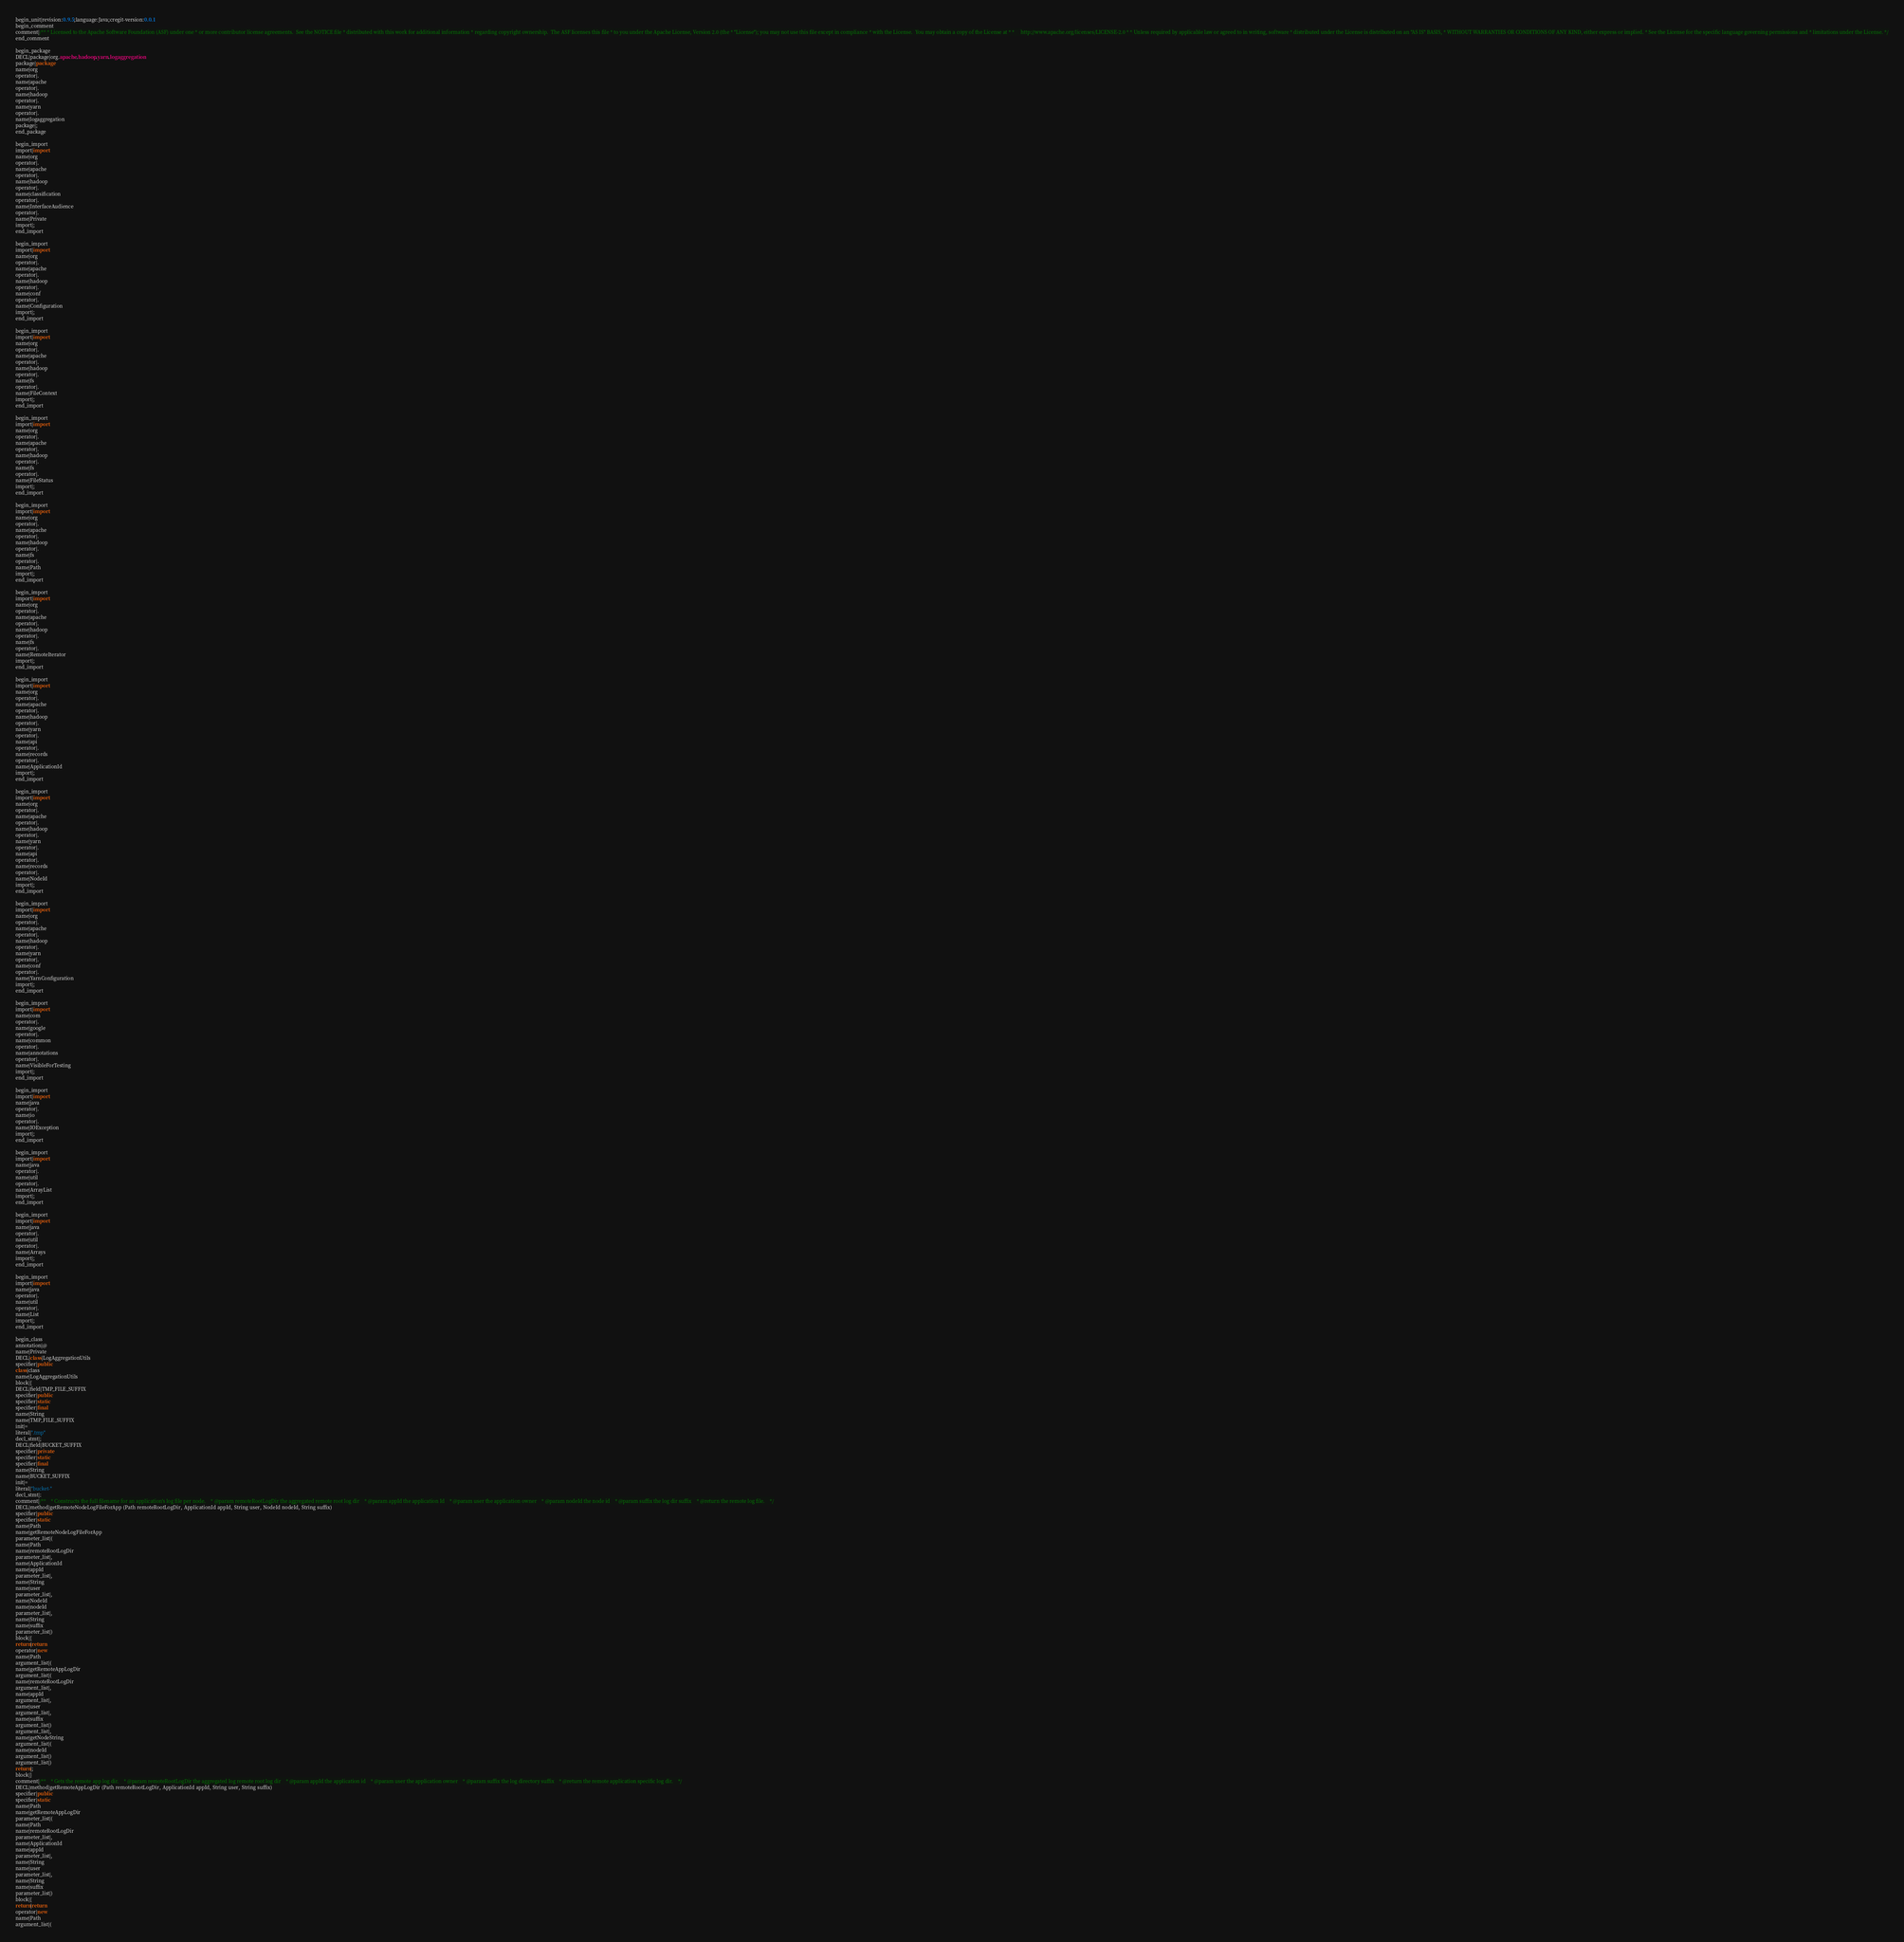Convert code to text. <code><loc_0><loc_0><loc_500><loc_500><_Java_>begin_unit|revision:0.9.5;language:Java;cregit-version:0.0.1
begin_comment
comment|/** * Licensed to the Apache Software Foundation (ASF) under one * or more contributor license agreements.  See the NOTICE file * distributed with this work for additional information * regarding copyright ownership.  The ASF licenses this file * to you under the Apache License, Version 2.0 (the * "License"); you may not use this file except in compliance * with the License.  You may obtain a copy of the License at * *     http://www.apache.org/licenses/LICENSE-2.0 * * Unless required by applicable law or agreed to in writing, software * distributed under the License is distributed on an "AS IS" BASIS, * WITHOUT WARRANTIES OR CONDITIONS OF ANY KIND, either express or implied. * See the License for the specific language governing permissions and * limitations under the License. */
end_comment

begin_package
DECL|package|org.apache.hadoop.yarn.logaggregation
package|package
name|org
operator|.
name|apache
operator|.
name|hadoop
operator|.
name|yarn
operator|.
name|logaggregation
package|;
end_package

begin_import
import|import
name|org
operator|.
name|apache
operator|.
name|hadoop
operator|.
name|classification
operator|.
name|InterfaceAudience
operator|.
name|Private
import|;
end_import

begin_import
import|import
name|org
operator|.
name|apache
operator|.
name|hadoop
operator|.
name|conf
operator|.
name|Configuration
import|;
end_import

begin_import
import|import
name|org
operator|.
name|apache
operator|.
name|hadoop
operator|.
name|fs
operator|.
name|FileContext
import|;
end_import

begin_import
import|import
name|org
operator|.
name|apache
operator|.
name|hadoop
operator|.
name|fs
operator|.
name|FileStatus
import|;
end_import

begin_import
import|import
name|org
operator|.
name|apache
operator|.
name|hadoop
operator|.
name|fs
operator|.
name|Path
import|;
end_import

begin_import
import|import
name|org
operator|.
name|apache
operator|.
name|hadoop
operator|.
name|fs
operator|.
name|RemoteIterator
import|;
end_import

begin_import
import|import
name|org
operator|.
name|apache
operator|.
name|hadoop
operator|.
name|yarn
operator|.
name|api
operator|.
name|records
operator|.
name|ApplicationId
import|;
end_import

begin_import
import|import
name|org
operator|.
name|apache
operator|.
name|hadoop
operator|.
name|yarn
operator|.
name|api
operator|.
name|records
operator|.
name|NodeId
import|;
end_import

begin_import
import|import
name|org
operator|.
name|apache
operator|.
name|hadoop
operator|.
name|yarn
operator|.
name|conf
operator|.
name|YarnConfiguration
import|;
end_import

begin_import
import|import
name|com
operator|.
name|google
operator|.
name|common
operator|.
name|annotations
operator|.
name|VisibleForTesting
import|;
end_import

begin_import
import|import
name|java
operator|.
name|io
operator|.
name|IOException
import|;
end_import

begin_import
import|import
name|java
operator|.
name|util
operator|.
name|ArrayList
import|;
end_import

begin_import
import|import
name|java
operator|.
name|util
operator|.
name|Arrays
import|;
end_import

begin_import
import|import
name|java
operator|.
name|util
operator|.
name|List
import|;
end_import

begin_class
annotation|@
name|Private
DECL|class|LogAggregationUtils
specifier|public
class|class
name|LogAggregationUtils
block|{
DECL|field|TMP_FILE_SUFFIX
specifier|public
specifier|static
specifier|final
name|String
name|TMP_FILE_SUFFIX
init|=
literal|".tmp"
decl_stmt|;
DECL|field|BUCKET_SUFFIX
specifier|private
specifier|static
specifier|final
name|String
name|BUCKET_SUFFIX
init|=
literal|"bucket-"
decl_stmt|;
comment|/**    * Constructs the full filename for an application's log file per node.    * @param remoteRootLogDir the aggregated remote root log dir    * @param appId the application Id    * @param user the application owner    * @param nodeId the node id    * @param suffix the log dir suffix    * @return the remote log file.    */
DECL|method|getRemoteNodeLogFileForApp (Path remoteRootLogDir, ApplicationId appId, String user, NodeId nodeId, String suffix)
specifier|public
specifier|static
name|Path
name|getRemoteNodeLogFileForApp
parameter_list|(
name|Path
name|remoteRootLogDir
parameter_list|,
name|ApplicationId
name|appId
parameter_list|,
name|String
name|user
parameter_list|,
name|NodeId
name|nodeId
parameter_list|,
name|String
name|suffix
parameter_list|)
block|{
return|return
operator|new
name|Path
argument_list|(
name|getRemoteAppLogDir
argument_list|(
name|remoteRootLogDir
argument_list|,
name|appId
argument_list|,
name|user
argument_list|,
name|suffix
argument_list|)
argument_list|,
name|getNodeString
argument_list|(
name|nodeId
argument_list|)
argument_list|)
return|;
block|}
comment|/**    * Gets the remote app log dir.    * @param remoteRootLogDir the aggregated log remote root log dir    * @param appId the application id    * @param user the application owner    * @param suffix the log directory suffix    * @return the remote application specific log dir.    */
DECL|method|getRemoteAppLogDir (Path remoteRootLogDir, ApplicationId appId, String user, String suffix)
specifier|public
specifier|static
name|Path
name|getRemoteAppLogDir
parameter_list|(
name|Path
name|remoteRootLogDir
parameter_list|,
name|ApplicationId
name|appId
parameter_list|,
name|String
name|user
parameter_list|,
name|String
name|suffix
parameter_list|)
block|{
return|return
operator|new
name|Path
argument_list|(</code> 